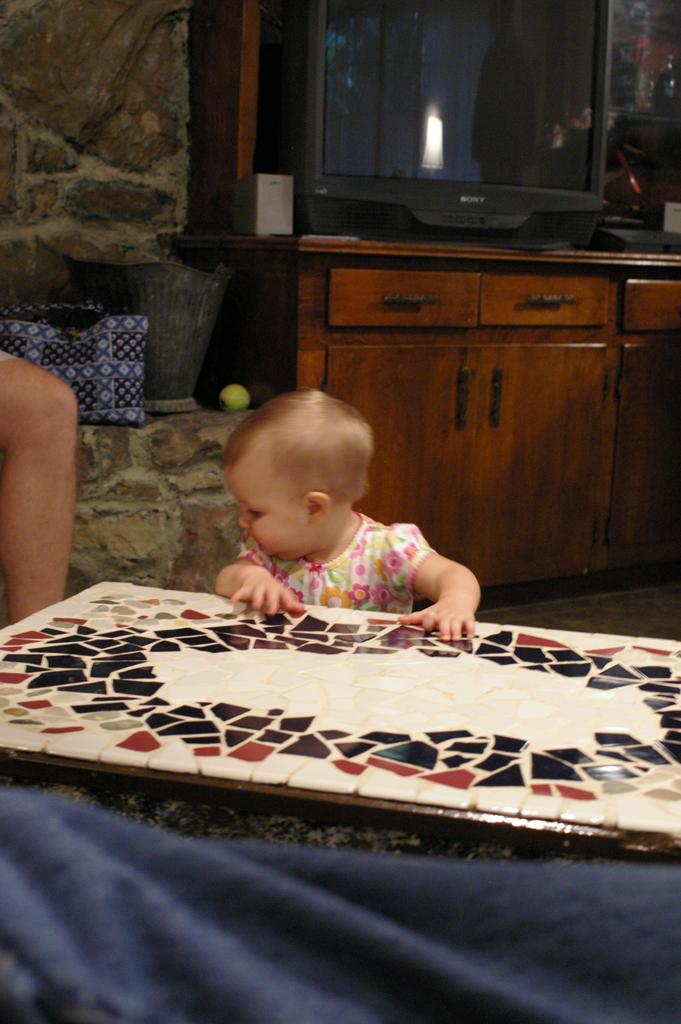What is the main subject of the image? There is a baby in the image. Where is the baby located in relation to the table? The baby is in front of a table. What can be seen in the background of the image? There is a TV on a table in the background of the image. What type of sponge is the baby using to clean the table in the image? There is no sponge present in the image, and the baby is not cleaning the table. 